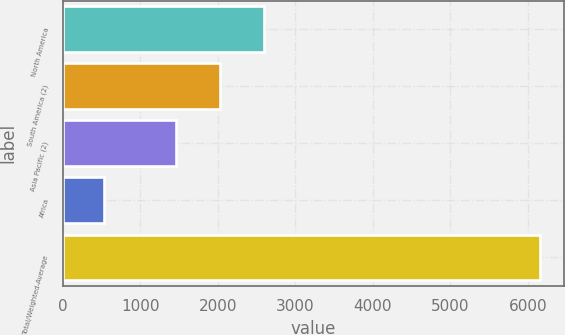<chart> <loc_0><loc_0><loc_500><loc_500><bar_chart><fcel>North America<fcel>South America (2)<fcel>Asia Pacific (2)<fcel>Africa<fcel>Total/Weighted-Average<nl><fcel>2589.6<fcel>2026.8<fcel>1464<fcel>525<fcel>6153<nl></chart> 